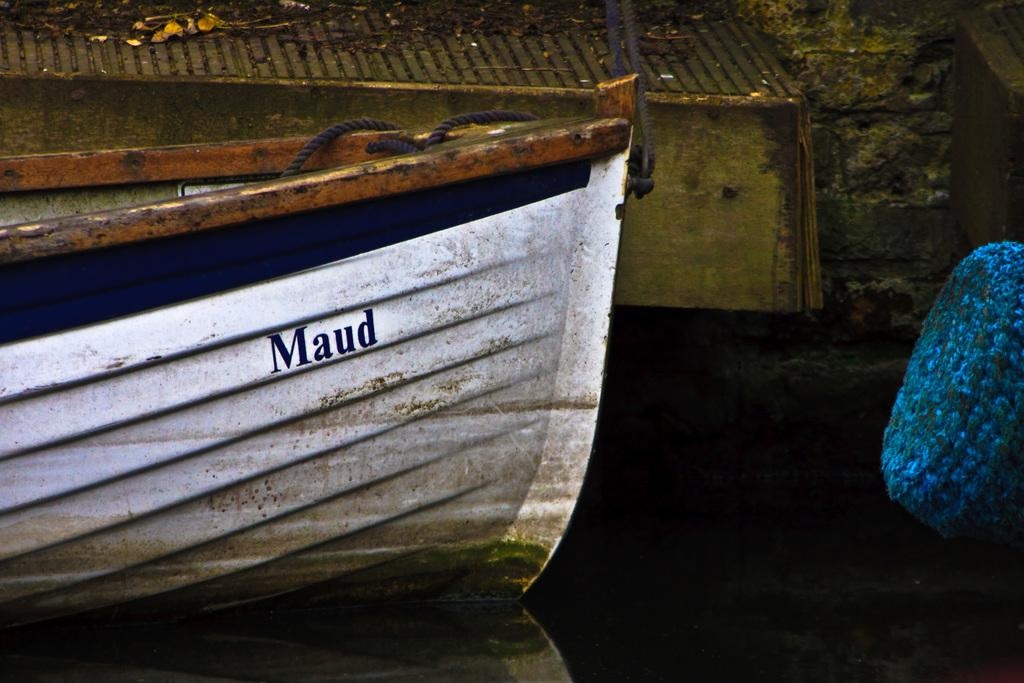What is the main subject of the image? The main subject of the image is a boat. Where is the boat located? The boat is on a river. What else can be seen on the right side of the image? There is an object towards the right side of the image. What is visible at the top of the image? There is a wall visible at the top of the image. What nation is represented by the flag on the boat in the image? There is no flag visible on the boat in the image, so it is not possible to determine which nation it might represent. 